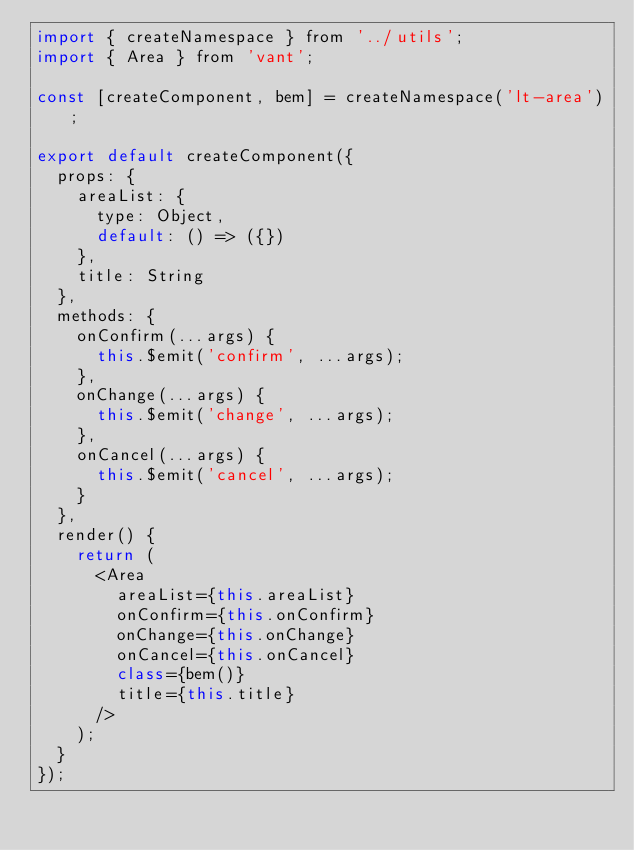Convert code to text. <code><loc_0><loc_0><loc_500><loc_500><_JavaScript_>import { createNamespace } from '../utils';
import { Area } from 'vant';

const [createComponent, bem] = createNamespace('lt-area');

export default createComponent({
  props: {
    areaList: {
      type: Object,
      default: () => ({})
    },
    title: String
  },
  methods: {
    onConfirm(...args) {
      this.$emit('confirm', ...args);
    },
    onChange(...args) {
      this.$emit('change', ...args);
    },
    onCancel(...args) {
      this.$emit('cancel', ...args);
    }
  },
  render() {
    return (
      <Area
        areaList={this.areaList}
        onConfirm={this.onConfirm}
        onChange={this.onChange}
        onCancel={this.onCancel}
        class={bem()}
        title={this.title}
      />
    );
  }
});
</code> 